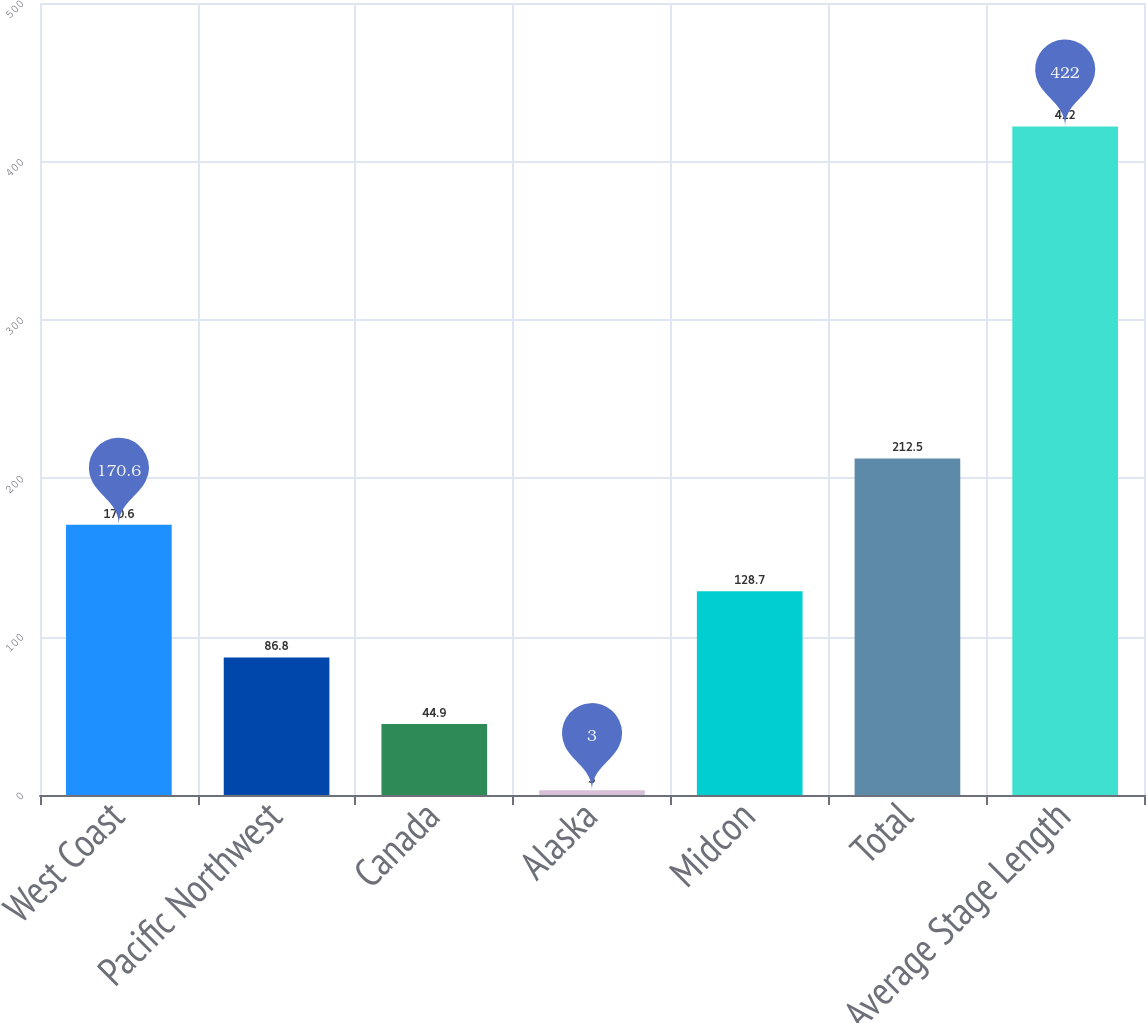Convert chart to OTSL. <chart><loc_0><loc_0><loc_500><loc_500><bar_chart><fcel>West Coast<fcel>Pacific Northwest<fcel>Canada<fcel>Alaska<fcel>Midcon<fcel>Total<fcel>Average Stage Length<nl><fcel>170.6<fcel>86.8<fcel>44.9<fcel>3<fcel>128.7<fcel>212.5<fcel>422<nl></chart> 